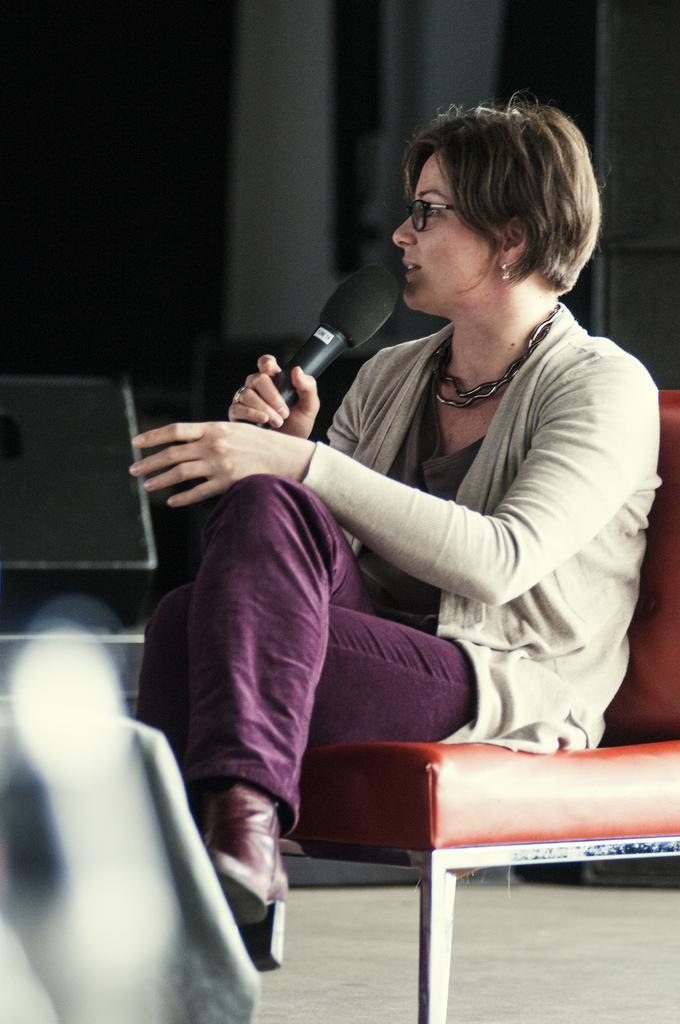Who is the main subject in the image? There is a woman in the image. What is the woman doing in the image? The woman is sitting on a chair and holding a microphone. What can be seen in the background of the image? There is a wall in the background of the image. What type of cheese is being used to cover the fire in the image? There is no cheese or fire present in the image. 